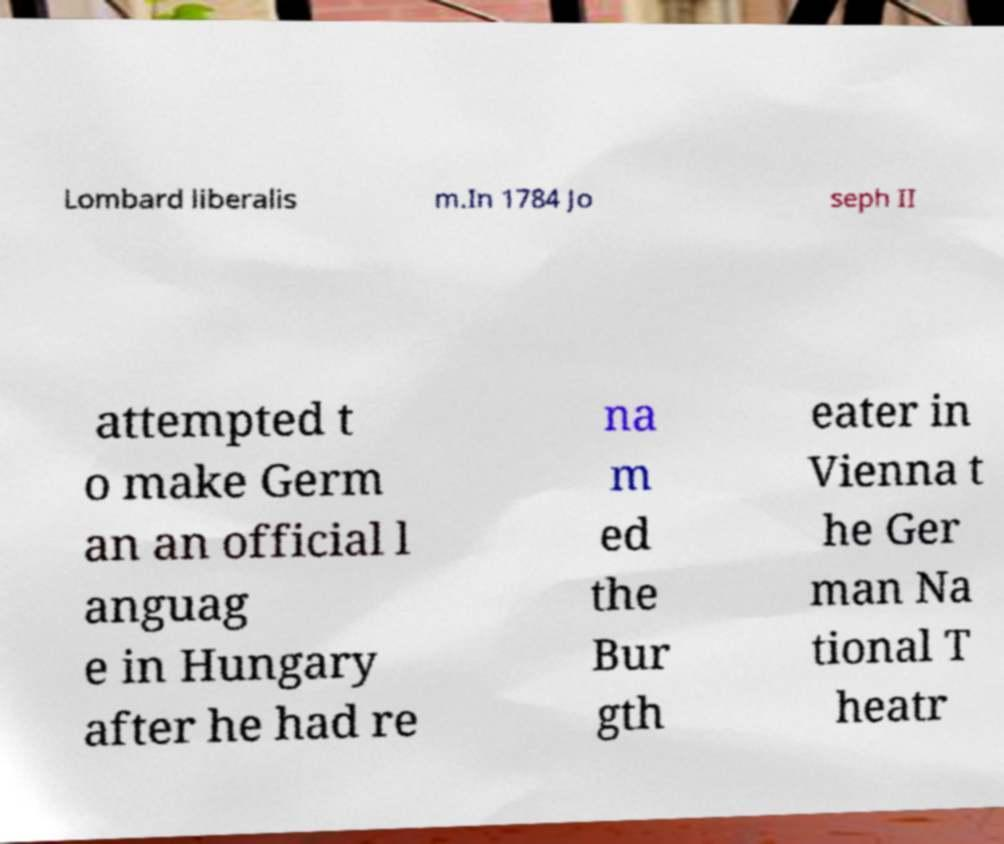For documentation purposes, I need the text within this image transcribed. Could you provide that? Lombard liberalis m.In 1784 Jo seph II attempted t o make Germ an an official l anguag e in Hungary after he had re na m ed the Bur gth eater in Vienna t he Ger man Na tional T heatr 